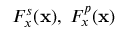Convert formula to latex. <formula><loc_0><loc_0><loc_500><loc_500>F _ { x } ^ { s } ( x ) , \, F _ { x } ^ { p } ( x )</formula> 